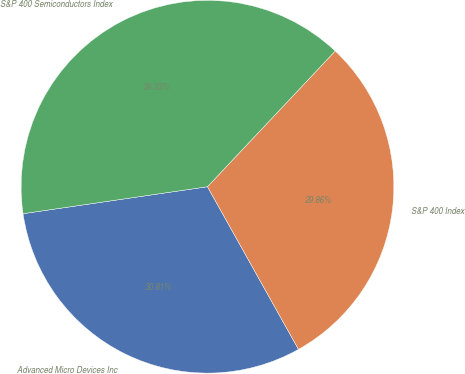Convert chart to OTSL. <chart><loc_0><loc_0><loc_500><loc_500><pie_chart><fcel>Advanced Micro Devices Inc<fcel>S&P 400 Index<fcel>S&P 400 Semiconductors Index<nl><fcel>30.81%<fcel>29.86%<fcel>39.33%<nl></chart> 